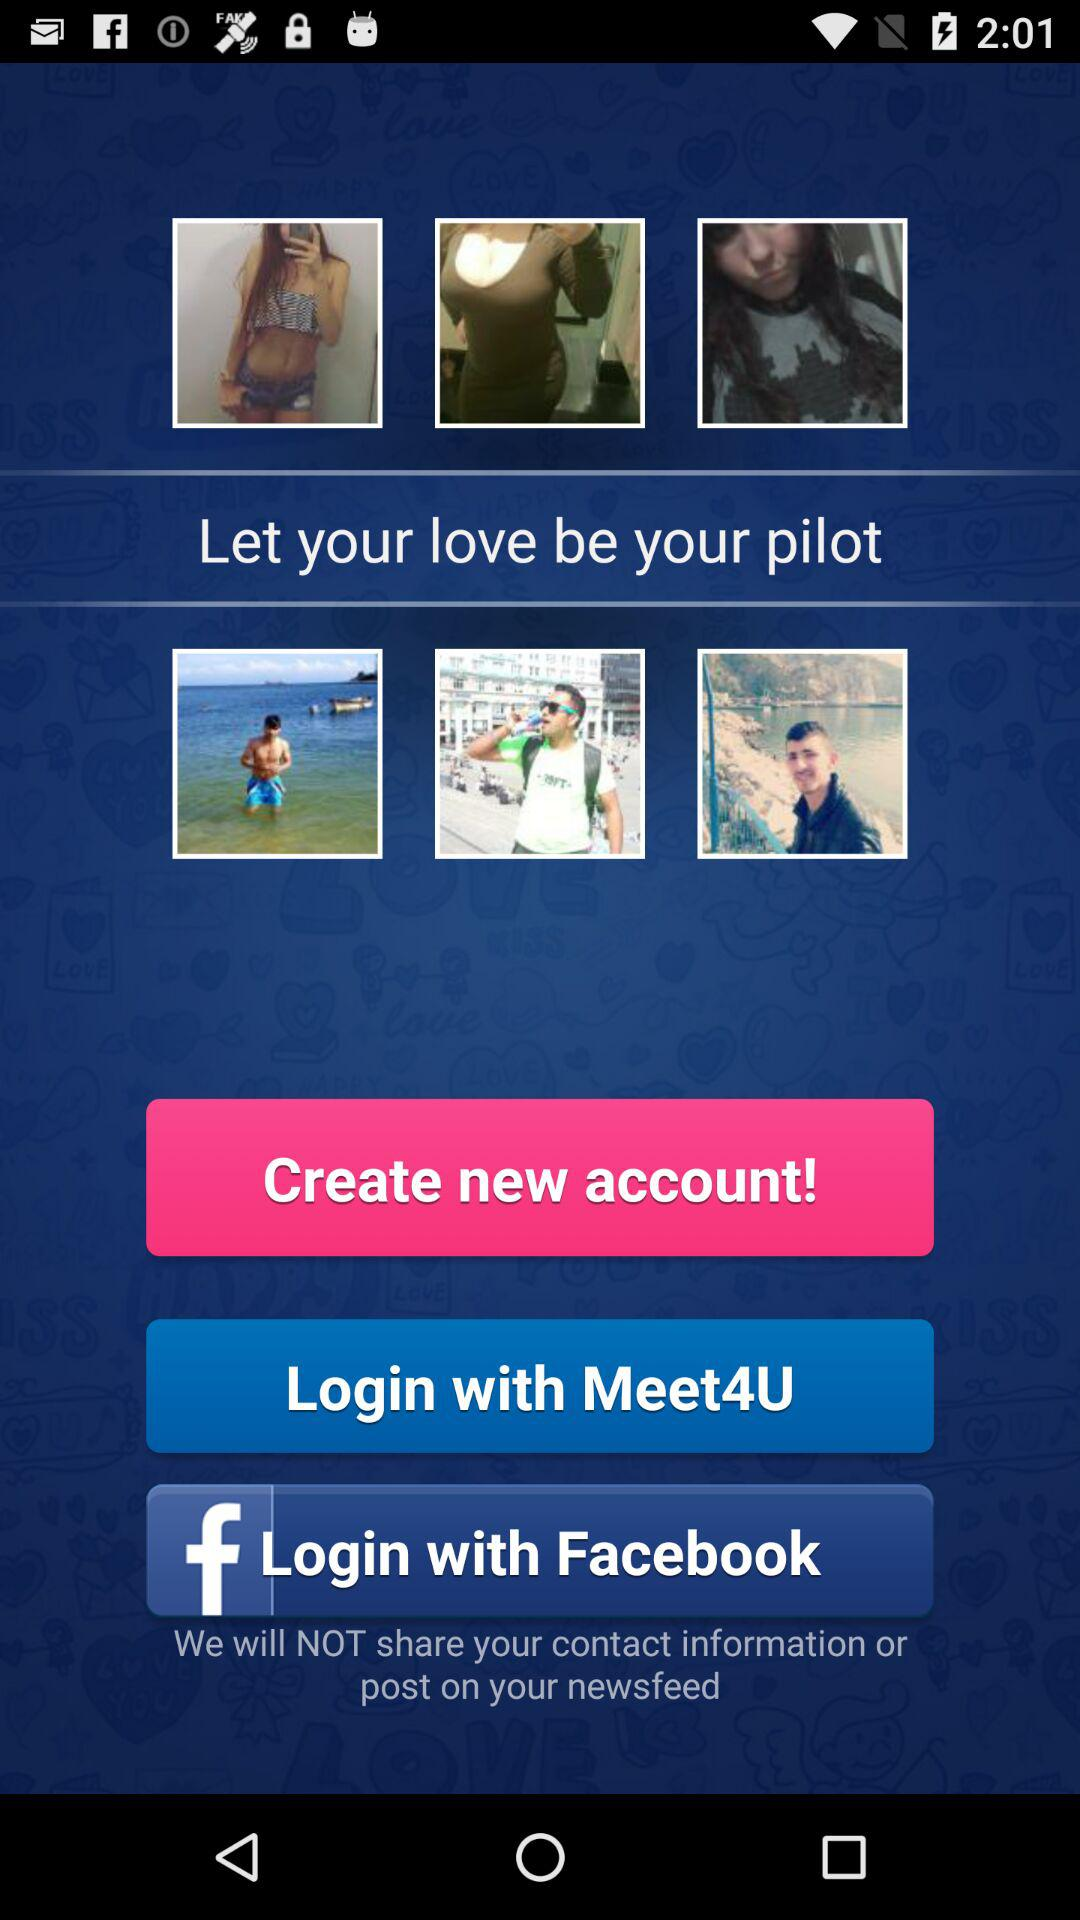What is the username to login?
When the provided information is insufficient, respond with <no answer>. <no answer> 